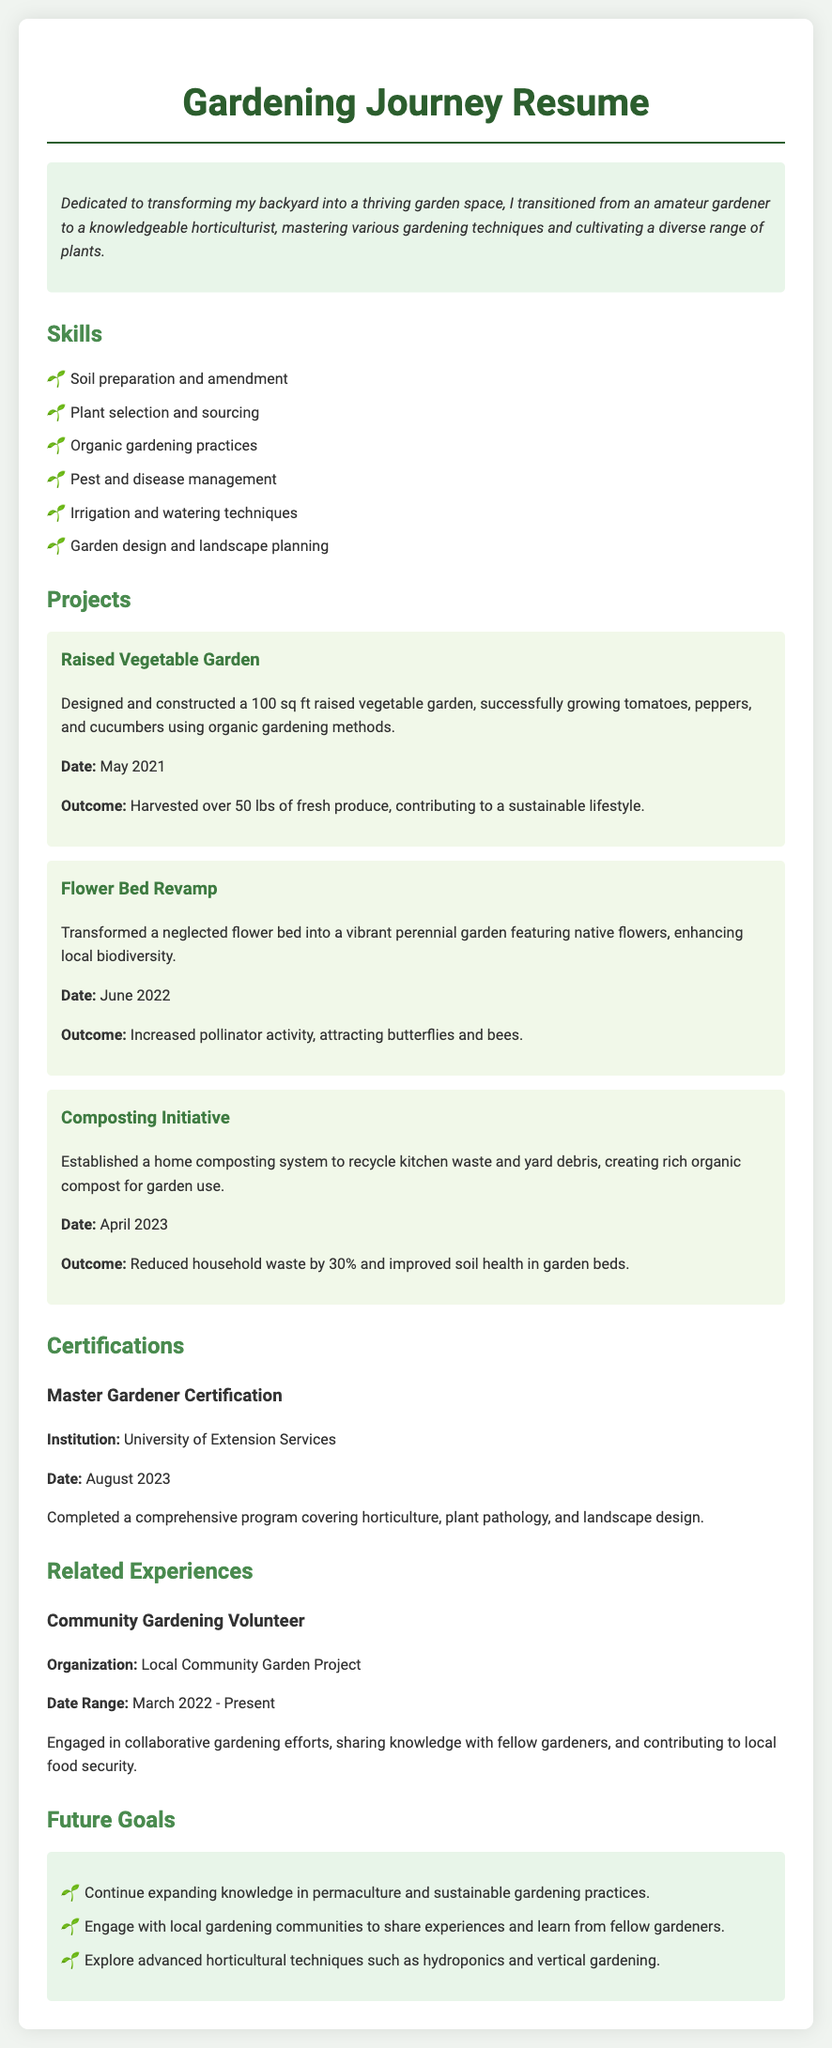what is the title of the document? The title of the document is stated at the top and provides insight into the content, which is "Gardening Journey Resume."
Answer: Gardening Journey Resume what is the date of completion for the Master Gardener Certification? The date of completion for the certification is mentioned under the certification section, highlighting when the course was finished.
Answer: August 2023 how many pounds of produce were harvested from the raised vegetable garden? The outcome from the raised vegetable garden project specifies the weight of the harvested produce and indicates the successful results of the efforts.
Answer: 50 lbs which organization was involved in the Community Gardening Volunteer experience? The organization is identified within the experience section, indicating where the volunteer efforts were dedicated and which community project was engaged in.
Answer: Local Community Garden Project what gardening technique is highlighted by establishing a home composting system? The initiative illustrates a sustainable practice focusing on waste reduction and soil health improvement, showcasing environmental awareness.
Answer: Composting what type of gardening practices does the person aim to expand knowledge in? The future goals section lists specific areas of focus, directing attention to ongoing learning and gardening enhancement aspirations.
Answer: Permaculture what project did the person undertake in June 2022? The project undertaken in June 2022 is detailed under the projects section, indicating the nature and timing of this particular gardening endeavor.
Answer: Flower Bed Revamp what is the area of the raised vegetable garden constructed? The size of the raised vegetable garden is specified in square feet, reflecting the scale of the gardening project.
Answer: 100 sq ft how did the flower bed revamp contribute to local biodiversity? The outcome of the flower bed project provides insight into its impact on the ecosystem, reflecting the ecological involvement of the gardening efforts.
Answer: Increased pollinator activity 